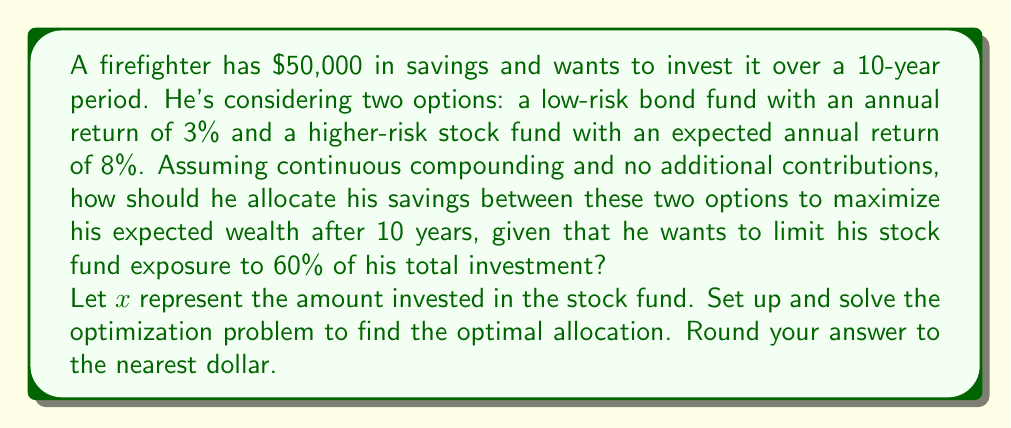Could you help me with this problem? To solve this problem, we'll follow these steps:

1) Set up the wealth function:
   Let $W(x)$ be the total wealth after 10 years.
   $W(x) = xe^{0.08 * 10} + (50000-x)e^{0.03 * 10}$

2) The constraint is that the stock fund exposure should be limited to 60% of the total investment:
   $x \leq 0.6 * 50000 = 30000$

3) To find the maximum, we need to differentiate $W(x)$ with respect to $x$:
   $$\frac{dW}{dx} = e^{0.08 * 10} - e^{0.03 * 10}$$

4) This derivative is always positive because $e^{0.08 * 10} > e^{0.03 * 10}$, which means $W(x)$ is always increasing with respect to $x$.

5) Therefore, the maximum value of $W(x)$ will occur at the upper limit of $x$, which is $30000.

6) Calculate the optimal allocation:
   Stock fund: $30000
   Bond fund: $50000 - $30000 = $20000

7) Verify the final wealth:
   $W(30000) = 30000e^{0.08 * 10} + 20000e^{0.03 * 10}$
             $= 30000 * 2.225541 + 20000 * 1.349859$
             $= 66766.23 + 26997.18$
             $= 93763.41$
Answer: The optimal allocation is $30,000 in the stock fund and $20,000 in the bond fund, resulting in a total wealth of $93,763 after 10 years. 